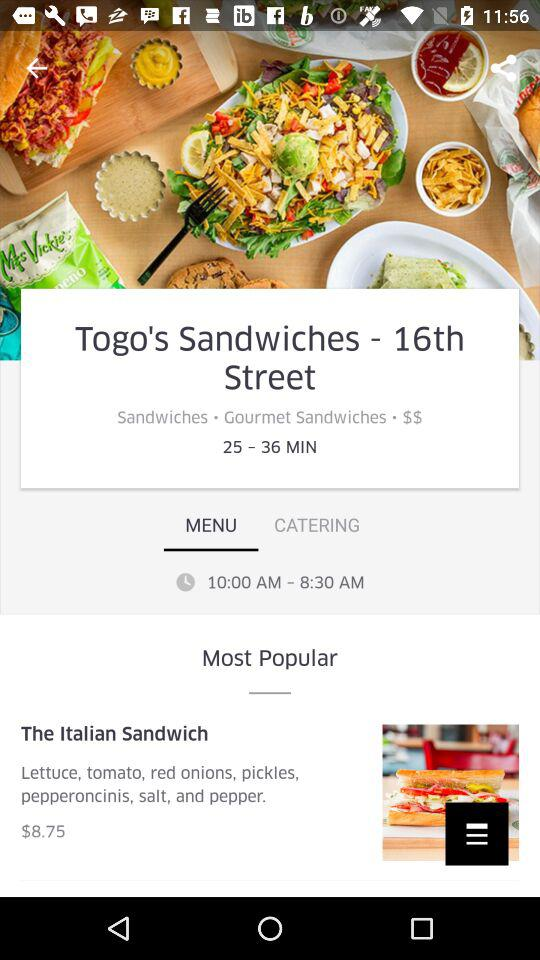What is the location? The location is 16th Street. 